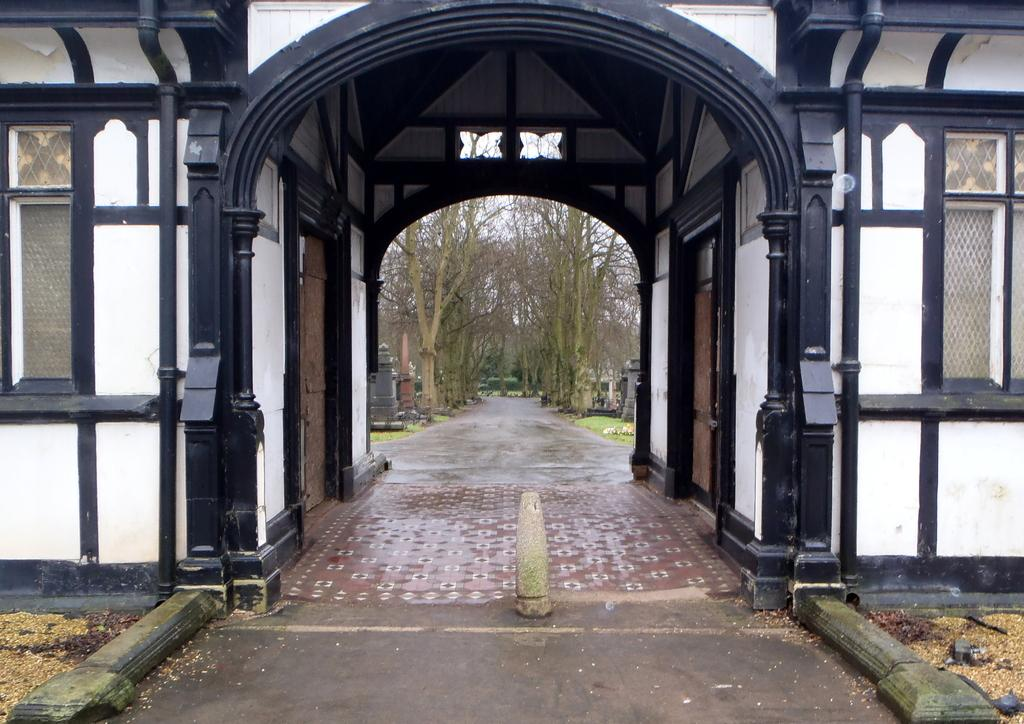What can be seen running through the image? There is a path in the image. What is located between the path? There is a building between the path. How is the path covered in the image? The path is created under a roof of an arch. What type of hook can be seen hanging from the building in the image? There is no hook present in the image; it only features a path, a building, and a roof of an arch. 